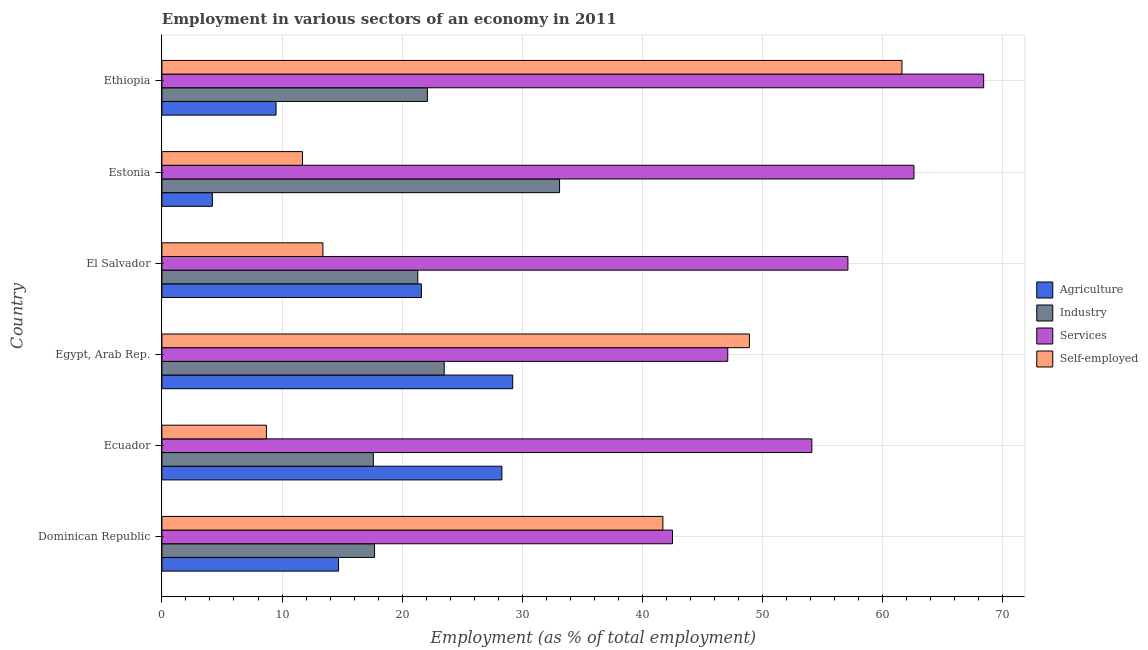How many different coloured bars are there?
Your answer should be very brief. 4. How many groups of bars are there?
Provide a short and direct response. 6. Are the number of bars per tick equal to the number of legend labels?
Give a very brief answer. Yes. Are the number of bars on each tick of the Y-axis equal?
Provide a short and direct response. Yes. How many bars are there on the 4th tick from the top?
Make the answer very short. 4. How many bars are there on the 2nd tick from the bottom?
Make the answer very short. 4. What is the label of the 5th group of bars from the top?
Make the answer very short. Ecuador. In how many cases, is the number of bars for a given country not equal to the number of legend labels?
Provide a succinct answer. 0. What is the percentage of workers in services in Dominican Republic?
Your response must be concise. 42.5. Across all countries, what is the maximum percentage of workers in industry?
Offer a very short reply. 33.1. Across all countries, what is the minimum percentage of workers in agriculture?
Your response must be concise. 4.2. In which country was the percentage of workers in agriculture maximum?
Provide a succinct answer. Egypt, Arab Rep. In which country was the percentage of self employed workers minimum?
Give a very brief answer. Ecuador. What is the total percentage of workers in industry in the graph?
Provide a succinct answer. 135.3. What is the difference between the percentage of workers in services in Dominican Republic and that in Estonia?
Provide a short and direct response. -20.1. What is the difference between the percentage of self employed workers in Ethiopia and the percentage of workers in services in Egypt, Arab Rep.?
Keep it short and to the point. 14.5. What is the average percentage of workers in agriculture per country?
Provide a short and direct response. 17.92. What is the difference between the percentage of workers in agriculture and percentage of workers in industry in Estonia?
Give a very brief answer. -28.9. In how many countries, is the percentage of workers in industry greater than 4 %?
Ensure brevity in your answer.  6. What is the ratio of the percentage of workers in agriculture in Ecuador to that in Ethiopia?
Offer a very short reply. 2.98. Is the percentage of workers in agriculture in Dominican Republic less than that in Ecuador?
Offer a very short reply. Yes. Is the difference between the percentage of workers in services in Estonia and Ethiopia greater than the difference between the percentage of workers in agriculture in Estonia and Ethiopia?
Your answer should be very brief. No. What is the difference between the highest and the lowest percentage of self employed workers?
Offer a terse response. 52.9. In how many countries, is the percentage of workers in industry greater than the average percentage of workers in industry taken over all countries?
Ensure brevity in your answer.  2. Is it the case that in every country, the sum of the percentage of workers in agriculture and percentage of workers in services is greater than the sum of percentage of self employed workers and percentage of workers in industry?
Give a very brief answer. Yes. What does the 3rd bar from the top in Estonia represents?
Keep it short and to the point. Industry. What does the 2nd bar from the bottom in Ecuador represents?
Your answer should be very brief. Industry. Is it the case that in every country, the sum of the percentage of workers in agriculture and percentage of workers in industry is greater than the percentage of workers in services?
Offer a very short reply. No. Are all the bars in the graph horizontal?
Give a very brief answer. Yes. How many countries are there in the graph?
Your answer should be very brief. 6. What is the difference between two consecutive major ticks on the X-axis?
Your response must be concise. 10. Are the values on the major ticks of X-axis written in scientific E-notation?
Provide a short and direct response. No. Does the graph contain any zero values?
Ensure brevity in your answer.  No. Does the graph contain grids?
Your answer should be compact. Yes. Where does the legend appear in the graph?
Provide a short and direct response. Center right. How are the legend labels stacked?
Ensure brevity in your answer.  Vertical. What is the title of the graph?
Offer a terse response. Employment in various sectors of an economy in 2011. Does "Belgium" appear as one of the legend labels in the graph?
Your response must be concise. No. What is the label or title of the X-axis?
Keep it short and to the point. Employment (as % of total employment). What is the Employment (as % of total employment) in Agriculture in Dominican Republic?
Provide a succinct answer. 14.7. What is the Employment (as % of total employment) in Industry in Dominican Republic?
Keep it short and to the point. 17.7. What is the Employment (as % of total employment) in Services in Dominican Republic?
Your answer should be very brief. 42.5. What is the Employment (as % of total employment) of Self-employed in Dominican Republic?
Offer a terse response. 41.7. What is the Employment (as % of total employment) in Agriculture in Ecuador?
Give a very brief answer. 28.3. What is the Employment (as % of total employment) of Industry in Ecuador?
Keep it short and to the point. 17.6. What is the Employment (as % of total employment) in Services in Ecuador?
Your answer should be very brief. 54.1. What is the Employment (as % of total employment) in Self-employed in Ecuador?
Keep it short and to the point. 8.7. What is the Employment (as % of total employment) in Agriculture in Egypt, Arab Rep.?
Your answer should be compact. 29.2. What is the Employment (as % of total employment) of Services in Egypt, Arab Rep.?
Keep it short and to the point. 47.1. What is the Employment (as % of total employment) of Self-employed in Egypt, Arab Rep.?
Make the answer very short. 48.9. What is the Employment (as % of total employment) of Agriculture in El Salvador?
Offer a very short reply. 21.6. What is the Employment (as % of total employment) of Industry in El Salvador?
Make the answer very short. 21.3. What is the Employment (as % of total employment) of Services in El Salvador?
Give a very brief answer. 57.1. What is the Employment (as % of total employment) in Self-employed in El Salvador?
Offer a very short reply. 13.4. What is the Employment (as % of total employment) of Agriculture in Estonia?
Ensure brevity in your answer.  4.2. What is the Employment (as % of total employment) in Industry in Estonia?
Keep it short and to the point. 33.1. What is the Employment (as % of total employment) of Services in Estonia?
Offer a very short reply. 62.6. What is the Employment (as % of total employment) of Self-employed in Estonia?
Provide a succinct answer. 11.7. What is the Employment (as % of total employment) in Agriculture in Ethiopia?
Offer a very short reply. 9.5. What is the Employment (as % of total employment) in Industry in Ethiopia?
Ensure brevity in your answer.  22.1. What is the Employment (as % of total employment) of Services in Ethiopia?
Provide a short and direct response. 68.4. What is the Employment (as % of total employment) of Self-employed in Ethiopia?
Offer a very short reply. 61.6. Across all countries, what is the maximum Employment (as % of total employment) in Agriculture?
Give a very brief answer. 29.2. Across all countries, what is the maximum Employment (as % of total employment) of Industry?
Offer a very short reply. 33.1. Across all countries, what is the maximum Employment (as % of total employment) of Services?
Make the answer very short. 68.4. Across all countries, what is the maximum Employment (as % of total employment) of Self-employed?
Provide a short and direct response. 61.6. Across all countries, what is the minimum Employment (as % of total employment) of Agriculture?
Offer a terse response. 4.2. Across all countries, what is the minimum Employment (as % of total employment) of Industry?
Ensure brevity in your answer.  17.6. Across all countries, what is the minimum Employment (as % of total employment) in Services?
Provide a succinct answer. 42.5. Across all countries, what is the minimum Employment (as % of total employment) of Self-employed?
Your answer should be very brief. 8.7. What is the total Employment (as % of total employment) in Agriculture in the graph?
Provide a succinct answer. 107.5. What is the total Employment (as % of total employment) of Industry in the graph?
Your answer should be compact. 135.3. What is the total Employment (as % of total employment) in Services in the graph?
Give a very brief answer. 331.8. What is the total Employment (as % of total employment) in Self-employed in the graph?
Your answer should be compact. 186. What is the difference between the Employment (as % of total employment) in Services in Dominican Republic and that in Ecuador?
Provide a short and direct response. -11.6. What is the difference between the Employment (as % of total employment) in Self-employed in Dominican Republic and that in Ecuador?
Your response must be concise. 33. What is the difference between the Employment (as % of total employment) of Industry in Dominican Republic and that in Egypt, Arab Rep.?
Provide a short and direct response. -5.8. What is the difference between the Employment (as % of total employment) of Agriculture in Dominican Republic and that in El Salvador?
Make the answer very short. -6.9. What is the difference between the Employment (as % of total employment) in Industry in Dominican Republic and that in El Salvador?
Your answer should be compact. -3.6. What is the difference between the Employment (as % of total employment) in Services in Dominican Republic and that in El Salvador?
Provide a succinct answer. -14.6. What is the difference between the Employment (as % of total employment) of Self-employed in Dominican Republic and that in El Salvador?
Give a very brief answer. 28.3. What is the difference between the Employment (as % of total employment) of Agriculture in Dominican Republic and that in Estonia?
Provide a succinct answer. 10.5. What is the difference between the Employment (as % of total employment) in Industry in Dominican Republic and that in Estonia?
Make the answer very short. -15.4. What is the difference between the Employment (as % of total employment) of Services in Dominican Republic and that in Estonia?
Provide a succinct answer. -20.1. What is the difference between the Employment (as % of total employment) of Agriculture in Dominican Republic and that in Ethiopia?
Keep it short and to the point. 5.2. What is the difference between the Employment (as % of total employment) of Industry in Dominican Republic and that in Ethiopia?
Your answer should be very brief. -4.4. What is the difference between the Employment (as % of total employment) in Services in Dominican Republic and that in Ethiopia?
Your response must be concise. -25.9. What is the difference between the Employment (as % of total employment) in Self-employed in Dominican Republic and that in Ethiopia?
Provide a short and direct response. -19.9. What is the difference between the Employment (as % of total employment) of Agriculture in Ecuador and that in Egypt, Arab Rep.?
Give a very brief answer. -0.9. What is the difference between the Employment (as % of total employment) of Self-employed in Ecuador and that in Egypt, Arab Rep.?
Give a very brief answer. -40.2. What is the difference between the Employment (as % of total employment) of Industry in Ecuador and that in El Salvador?
Offer a very short reply. -3.7. What is the difference between the Employment (as % of total employment) in Services in Ecuador and that in El Salvador?
Provide a short and direct response. -3. What is the difference between the Employment (as % of total employment) in Self-employed in Ecuador and that in El Salvador?
Your response must be concise. -4.7. What is the difference between the Employment (as % of total employment) in Agriculture in Ecuador and that in Estonia?
Make the answer very short. 24.1. What is the difference between the Employment (as % of total employment) of Industry in Ecuador and that in Estonia?
Offer a very short reply. -15.5. What is the difference between the Employment (as % of total employment) of Services in Ecuador and that in Estonia?
Your answer should be compact. -8.5. What is the difference between the Employment (as % of total employment) of Agriculture in Ecuador and that in Ethiopia?
Your answer should be very brief. 18.8. What is the difference between the Employment (as % of total employment) in Services in Ecuador and that in Ethiopia?
Make the answer very short. -14.3. What is the difference between the Employment (as % of total employment) of Self-employed in Ecuador and that in Ethiopia?
Provide a short and direct response. -52.9. What is the difference between the Employment (as % of total employment) of Industry in Egypt, Arab Rep. and that in El Salvador?
Ensure brevity in your answer.  2.2. What is the difference between the Employment (as % of total employment) of Self-employed in Egypt, Arab Rep. and that in El Salvador?
Your answer should be very brief. 35.5. What is the difference between the Employment (as % of total employment) of Services in Egypt, Arab Rep. and that in Estonia?
Provide a short and direct response. -15.5. What is the difference between the Employment (as % of total employment) of Self-employed in Egypt, Arab Rep. and that in Estonia?
Your answer should be very brief. 37.2. What is the difference between the Employment (as % of total employment) in Services in Egypt, Arab Rep. and that in Ethiopia?
Ensure brevity in your answer.  -21.3. What is the difference between the Employment (as % of total employment) of Self-employed in Egypt, Arab Rep. and that in Ethiopia?
Keep it short and to the point. -12.7. What is the difference between the Employment (as % of total employment) in Agriculture in El Salvador and that in Estonia?
Your response must be concise. 17.4. What is the difference between the Employment (as % of total employment) of Industry in El Salvador and that in Estonia?
Your answer should be very brief. -11.8. What is the difference between the Employment (as % of total employment) in Services in El Salvador and that in Estonia?
Your response must be concise. -5.5. What is the difference between the Employment (as % of total employment) in Self-employed in El Salvador and that in Estonia?
Provide a succinct answer. 1.7. What is the difference between the Employment (as % of total employment) in Industry in El Salvador and that in Ethiopia?
Offer a very short reply. -0.8. What is the difference between the Employment (as % of total employment) in Self-employed in El Salvador and that in Ethiopia?
Make the answer very short. -48.2. What is the difference between the Employment (as % of total employment) in Industry in Estonia and that in Ethiopia?
Your answer should be compact. 11. What is the difference between the Employment (as % of total employment) in Services in Estonia and that in Ethiopia?
Your answer should be very brief. -5.8. What is the difference between the Employment (as % of total employment) in Self-employed in Estonia and that in Ethiopia?
Ensure brevity in your answer.  -49.9. What is the difference between the Employment (as % of total employment) of Agriculture in Dominican Republic and the Employment (as % of total employment) of Industry in Ecuador?
Ensure brevity in your answer.  -2.9. What is the difference between the Employment (as % of total employment) of Agriculture in Dominican Republic and the Employment (as % of total employment) of Services in Ecuador?
Your answer should be very brief. -39.4. What is the difference between the Employment (as % of total employment) of Agriculture in Dominican Republic and the Employment (as % of total employment) of Self-employed in Ecuador?
Provide a short and direct response. 6. What is the difference between the Employment (as % of total employment) of Industry in Dominican Republic and the Employment (as % of total employment) of Services in Ecuador?
Keep it short and to the point. -36.4. What is the difference between the Employment (as % of total employment) in Industry in Dominican Republic and the Employment (as % of total employment) in Self-employed in Ecuador?
Offer a very short reply. 9. What is the difference between the Employment (as % of total employment) in Services in Dominican Republic and the Employment (as % of total employment) in Self-employed in Ecuador?
Provide a succinct answer. 33.8. What is the difference between the Employment (as % of total employment) in Agriculture in Dominican Republic and the Employment (as % of total employment) in Industry in Egypt, Arab Rep.?
Offer a very short reply. -8.8. What is the difference between the Employment (as % of total employment) of Agriculture in Dominican Republic and the Employment (as % of total employment) of Services in Egypt, Arab Rep.?
Your response must be concise. -32.4. What is the difference between the Employment (as % of total employment) in Agriculture in Dominican Republic and the Employment (as % of total employment) in Self-employed in Egypt, Arab Rep.?
Keep it short and to the point. -34.2. What is the difference between the Employment (as % of total employment) of Industry in Dominican Republic and the Employment (as % of total employment) of Services in Egypt, Arab Rep.?
Provide a short and direct response. -29.4. What is the difference between the Employment (as % of total employment) in Industry in Dominican Republic and the Employment (as % of total employment) in Self-employed in Egypt, Arab Rep.?
Provide a succinct answer. -31.2. What is the difference between the Employment (as % of total employment) of Agriculture in Dominican Republic and the Employment (as % of total employment) of Services in El Salvador?
Your answer should be compact. -42.4. What is the difference between the Employment (as % of total employment) in Industry in Dominican Republic and the Employment (as % of total employment) in Services in El Salvador?
Provide a succinct answer. -39.4. What is the difference between the Employment (as % of total employment) of Industry in Dominican Republic and the Employment (as % of total employment) of Self-employed in El Salvador?
Provide a short and direct response. 4.3. What is the difference between the Employment (as % of total employment) in Services in Dominican Republic and the Employment (as % of total employment) in Self-employed in El Salvador?
Offer a very short reply. 29.1. What is the difference between the Employment (as % of total employment) in Agriculture in Dominican Republic and the Employment (as % of total employment) in Industry in Estonia?
Your answer should be very brief. -18.4. What is the difference between the Employment (as % of total employment) of Agriculture in Dominican Republic and the Employment (as % of total employment) of Services in Estonia?
Offer a terse response. -47.9. What is the difference between the Employment (as % of total employment) of Industry in Dominican Republic and the Employment (as % of total employment) of Services in Estonia?
Ensure brevity in your answer.  -44.9. What is the difference between the Employment (as % of total employment) in Industry in Dominican Republic and the Employment (as % of total employment) in Self-employed in Estonia?
Offer a terse response. 6. What is the difference between the Employment (as % of total employment) of Services in Dominican Republic and the Employment (as % of total employment) of Self-employed in Estonia?
Make the answer very short. 30.8. What is the difference between the Employment (as % of total employment) of Agriculture in Dominican Republic and the Employment (as % of total employment) of Industry in Ethiopia?
Provide a succinct answer. -7.4. What is the difference between the Employment (as % of total employment) of Agriculture in Dominican Republic and the Employment (as % of total employment) of Services in Ethiopia?
Offer a terse response. -53.7. What is the difference between the Employment (as % of total employment) of Agriculture in Dominican Republic and the Employment (as % of total employment) of Self-employed in Ethiopia?
Your response must be concise. -46.9. What is the difference between the Employment (as % of total employment) of Industry in Dominican Republic and the Employment (as % of total employment) of Services in Ethiopia?
Make the answer very short. -50.7. What is the difference between the Employment (as % of total employment) in Industry in Dominican Republic and the Employment (as % of total employment) in Self-employed in Ethiopia?
Offer a terse response. -43.9. What is the difference between the Employment (as % of total employment) in Services in Dominican Republic and the Employment (as % of total employment) in Self-employed in Ethiopia?
Give a very brief answer. -19.1. What is the difference between the Employment (as % of total employment) of Agriculture in Ecuador and the Employment (as % of total employment) of Services in Egypt, Arab Rep.?
Provide a succinct answer. -18.8. What is the difference between the Employment (as % of total employment) in Agriculture in Ecuador and the Employment (as % of total employment) in Self-employed in Egypt, Arab Rep.?
Provide a succinct answer. -20.6. What is the difference between the Employment (as % of total employment) of Industry in Ecuador and the Employment (as % of total employment) of Services in Egypt, Arab Rep.?
Your response must be concise. -29.5. What is the difference between the Employment (as % of total employment) of Industry in Ecuador and the Employment (as % of total employment) of Self-employed in Egypt, Arab Rep.?
Offer a very short reply. -31.3. What is the difference between the Employment (as % of total employment) of Agriculture in Ecuador and the Employment (as % of total employment) of Services in El Salvador?
Make the answer very short. -28.8. What is the difference between the Employment (as % of total employment) of Agriculture in Ecuador and the Employment (as % of total employment) of Self-employed in El Salvador?
Provide a short and direct response. 14.9. What is the difference between the Employment (as % of total employment) of Industry in Ecuador and the Employment (as % of total employment) of Services in El Salvador?
Make the answer very short. -39.5. What is the difference between the Employment (as % of total employment) in Industry in Ecuador and the Employment (as % of total employment) in Self-employed in El Salvador?
Keep it short and to the point. 4.2. What is the difference between the Employment (as % of total employment) of Services in Ecuador and the Employment (as % of total employment) of Self-employed in El Salvador?
Your response must be concise. 40.7. What is the difference between the Employment (as % of total employment) of Agriculture in Ecuador and the Employment (as % of total employment) of Services in Estonia?
Ensure brevity in your answer.  -34.3. What is the difference between the Employment (as % of total employment) in Agriculture in Ecuador and the Employment (as % of total employment) in Self-employed in Estonia?
Provide a short and direct response. 16.6. What is the difference between the Employment (as % of total employment) of Industry in Ecuador and the Employment (as % of total employment) of Services in Estonia?
Ensure brevity in your answer.  -45. What is the difference between the Employment (as % of total employment) of Industry in Ecuador and the Employment (as % of total employment) of Self-employed in Estonia?
Make the answer very short. 5.9. What is the difference between the Employment (as % of total employment) in Services in Ecuador and the Employment (as % of total employment) in Self-employed in Estonia?
Offer a very short reply. 42.4. What is the difference between the Employment (as % of total employment) in Agriculture in Ecuador and the Employment (as % of total employment) in Services in Ethiopia?
Keep it short and to the point. -40.1. What is the difference between the Employment (as % of total employment) of Agriculture in Ecuador and the Employment (as % of total employment) of Self-employed in Ethiopia?
Your answer should be very brief. -33.3. What is the difference between the Employment (as % of total employment) in Industry in Ecuador and the Employment (as % of total employment) in Services in Ethiopia?
Your answer should be very brief. -50.8. What is the difference between the Employment (as % of total employment) of Industry in Ecuador and the Employment (as % of total employment) of Self-employed in Ethiopia?
Give a very brief answer. -44. What is the difference between the Employment (as % of total employment) in Agriculture in Egypt, Arab Rep. and the Employment (as % of total employment) in Industry in El Salvador?
Offer a terse response. 7.9. What is the difference between the Employment (as % of total employment) of Agriculture in Egypt, Arab Rep. and the Employment (as % of total employment) of Services in El Salvador?
Provide a succinct answer. -27.9. What is the difference between the Employment (as % of total employment) of Agriculture in Egypt, Arab Rep. and the Employment (as % of total employment) of Self-employed in El Salvador?
Offer a terse response. 15.8. What is the difference between the Employment (as % of total employment) in Industry in Egypt, Arab Rep. and the Employment (as % of total employment) in Services in El Salvador?
Give a very brief answer. -33.6. What is the difference between the Employment (as % of total employment) in Industry in Egypt, Arab Rep. and the Employment (as % of total employment) in Self-employed in El Salvador?
Provide a short and direct response. 10.1. What is the difference between the Employment (as % of total employment) of Services in Egypt, Arab Rep. and the Employment (as % of total employment) of Self-employed in El Salvador?
Your response must be concise. 33.7. What is the difference between the Employment (as % of total employment) of Agriculture in Egypt, Arab Rep. and the Employment (as % of total employment) of Industry in Estonia?
Keep it short and to the point. -3.9. What is the difference between the Employment (as % of total employment) of Agriculture in Egypt, Arab Rep. and the Employment (as % of total employment) of Services in Estonia?
Ensure brevity in your answer.  -33.4. What is the difference between the Employment (as % of total employment) in Agriculture in Egypt, Arab Rep. and the Employment (as % of total employment) in Self-employed in Estonia?
Offer a very short reply. 17.5. What is the difference between the Employment (as % of total employment) of Industry in Egypt, Arab Rep. and the Employment (as % of total employment) of Services in Estonia?
Offer a terse response. -39.1. What is the difference between the Employment (as % of total employment) in Services in Egypt, Arab Rep. and the Employment (as % of total employment) in Self-employed in Estonia?
Make the answer very short. 35.4. What is the difference between the Employment (as % of total employment) of Agriculture in Egypt, Arab Rep. and the Employment (as % of total employment) of Services in Ethiopia?
Ensure brevity in your answer.  -39.2. What is the difference between the Employment (as % of total employment) of Agriculture in Egypt, Arab Rep. and the Employment (as % of total employment) of Self-employed in Ethiopia?
Offer a very short reply. -32.4. What is the difference between the Employment (as % of total employment) of Industry in Egypt, Arab Rep. and the Employment (as % of total employment) of Services in Ethiopia?
Offer a very short reply. -44.9. What is the difference between the Employment (as % of total employment) in Industry in Egypt, Arab Rep. and the Employment (as % of total employment) in Self-employed in Ethiopia?
Your response must be concise. -38.1. What is the difference between the Employment (as % of total employment) in Agriculture in El Salvador and the Employment (as % of total employment) in Services in Estonia?
Your answer should be compact. -41. What is the difference between the Employment (as % of total employment) in Agriculture in El Salvador and the Employment (as % of total employment) in Self-employed in Estonia?
Offer a very short reply. 9.9. What is the difference between the Employment (as % of total employment) in Industry in El Salvador and the Employment (as % of total employment) in Services in Estonia?
Offer a very short reply. -41.3. What is the difference between the Employment (as % of total employment) of Services in El Salvador and the Employment (as % of total employment) of Self-employed in Estonia?
Provide a short and direct response. 45.4. What is the difference between the Employment (as % of total employment) in Agriculture in El Salvador and the Employment (as % of total employment) in Services in Ethiopia?
Your answer should be very brief. -46.8. What is the difference between the Employment (as % of total employment) of Agriculture in El Salvador and the Employment (as % of total employment) of Self-employed in Ethiopia?
Your answer should be compact. -40. What is the difference between the Employment (as % of total employment) of Industry in El Salvador and the Employment (as % of total employment) of Services in Ethiopia?
Offer a very short reply. -47.1. What is the difference between the Employment (as % of total employment) in Industry in El Salvador and the Employment (as % of total employment) in Self-employed in Ethiopia?
Provide a short and direct response. -40.3. What is the difference between the Employment (as % of total employment) in Agriculture in Estonia and the Employment (as % of total employment) in Industry in Ethiopia?
Keep it short and to the point. -17.9. What is the difference between the Employment (as % of total employment) in Agriculture in Estonia and the Employment (as % of total employment) in Services in Ethiopia?
Your answer should be compact. -64.2. What is the difference between the Employment (as % of total employment) in Agriculture in Estonia and the Employment (as % of total employment) in Self-employed in Ethiopia?
Your response must be concise. -57.4. What is the difference between the Employment (as % of total employment) of Industry in Estonia and the Employment (as % of total employment) of Services in Ethiopia?
Offer a terse response. -35.3. What is the difference between the Employment (as % of total employment) of Industry in Estonia and the Employment (as % of total employment) of Self-employed in Ethiopia?
Offer a very short reply. -28.5. What is the average Employment (as % of total employment) of Agriculture per country?
Ensure brevity in your answer.  17.92. What is the average Employment (as % of total employment) in Industry per country?
Provide a short and direct response. 22.55. What is the average Employment (as % of total employment) in Services per country?
Ensure brevity in your answer.  55.3. What is the difference between the Employment (as % of total employment) in Agriculture and Employment (as % of total employment) in Industry in Dominican Republic?
Make the answer very short. -3. What is the difference between the Employment (as % of total employment) in Agriculture and Employment (as % of total employment) in Services in Dominican Republic?
Your response must be concise. -27.8. What is the difference between the Employment (as % of total employment) of Agriculture and Employment (as % of total employment) of Self-employed in Dominican Republic?
Provide a short and direct response. -27. What is the difference between the Employment (as % of total employment) in Industry and Employment (as % of total employment) in Services in Dominican Republic?
Keep it short and to the point. -24.8. What is the difference between the Employment (as % of total employment) in Agriculture and Employment (as % of total employment) in Industry in Ecuador?
Your answer should be very brief. 10.7. What is the difference between the Employment (as % of total employment) in Agriculture and Employment (as % of total employment) in Services in Ecuador?
Provide a succinct answer. -25.8. What is the difference between the Employment (as % of total employment) of Agriculture and Employment (as % of total employment) of Self-employed in Ecuador?
Provide a succinct answer. 19.6. What is the difference between the Employment (as % of total employment) of Industry and Employment (as % of total employment) of Services in Ecuador?
Provide a succinct answer. -36.5. What is the difference between the Employment (as % of total employment) of Industry and Employment (as % of total employment) of Self-employed in Ecuador?
Your answer should be very brief. 8.9. What is the difference between the Employment (as % of total employment) of Services and Employment (as % of total employment) of Self-employed in Ecuador?
Your response must be concise. 45.4. What is the difference between the Employment (as % of total employment) in Agriculture and Employment (as % of total employment) in Services in Egypt, Arab Rep.?
Your answer should be very brief. -17.9. What is the difference between the Employment (as % of total employment) in Agriculture and Employment (as % of total employment) in Self-employed in Egypt, Arab Rep.?
Give a very brief answer. -19.7. What is the difference between the Employment (as % of total employment) of Industry and Employment (as % of total employment) of Services in Egypt, Arab Rep.?
Your answer should be compact. -23.6. What is the difference between the Employment (as % of total employment) of Industry and Employment (as % of total employment) of Self-employed in Egypt, Arab Rep.?
Offer a very short reply. -25.4. What is the difference between the Employment (as % of total employment) in Agriculture and Employment (as % of total employment) in Services in El Salvador?
Keep it short and to the point. -35.5. What is the difference between the Employment (as % of total employment) in Industry and Employment (as % of total employment) in Services in El Salvador?
Provide a short and direct response. -35.8. What is the difference between the Employment (as % of total employment) of Services and Employment (as % of total employment) of Self-employed in El Salvador?
Provide a short and direct response. 43.7. What is the difference between the Employment (as % of total employment) in Agriculture and Employment (as % of total employment) in Industry in Estonia?
Provide a succinct answer. -28.9. What is the difference between the Employment (as % of total employment) in Agriculture and Employment (as % of total employment) in Services in Estonia?
Provide a short and direct response. -58.4. What is the difference between the Employment (as % of total employment) in Agriculture and Employment (as % of total employment) in Self-employed in Estonia?
Make the answer very short. -7.5. What is the difference between the Employment (as % of total employment) in Industry and Employment (as % of total employment) in Services in Estonia?
Offer a very short reply. -29.5. What is the difference between the Employment (as % of total employment) of Industry and Employment (as % of total employment) of Self-employed in Estonia?
Your response must be concise. 21.4. What is the difference between the Employment (as % of total employment) in Services and Employment (as % of total employment) in Self-employed in Estonia?
Ensure brevity in your answer.  50.9. What is the difference between the Employment (as % of total employment) in Agriculture and Employment (as % of total employment) in Services in Ethiopia?
Give a very brief answer. -58.9. What is the difference between the Employment (as % of total employment) in Agriculture and Employment (as % of total employment) in Self-employed in Ethiopia?
Offer a very short reply. -52.1. What is the difference between the Employment (as % of total employment) in Industry and Employment (as % of total employment) in Services in Ethiopia?
Offer a terse response. -46.3. What is the difference between the Employment (as % of total employment) of Industry and Employment (as % of total employment) of Self-employed in Ethiopia?
Your answer should be compact. -39.5. What is the difference between the Employment (as % of total employment) in Services and Employment (as % of total employment) in Self-employed in Ethiopia?
Your response must be concise. 6.8. What is the ratio of the Employment (as % of total employment) in Agriculture in Dominican Republic to that in Ecuador?
Provide a succinct answer. 0.52. What is the ratio of the Employment (as % of total employment) in Industry in Dominican Republic to that in Ecuador?
Your answer should be compact. 1.01. What is the ratio of the Employment (as % of total employment) in Services in Dominican Republic to that in Ecuador?
Your answer should be very brief. 0.79. What is the ratio of the Employment (as % of total employment) of Self-employed in Dominican Republic to that in Ecuador?
Give a very brief answer. 4.79. What is the ratio of the Employment (as % of total employment) in Agriculture in Dominican Republic to that in Egypt, Arab Rep.?
Ensure brevity in your answer.  0.5. What is the ratio of the Employment (as % of total employment) of Industry in Dominican Republic to that in Egypt, Arab Rep.?
Provide a succinct answer. 0.75. What is the ratio of the Employment (as % of total employment) of Services in Dominican Republic to that in Egypt, Arab Rep.?
Ensure brevity in your answer.  0.9. What is the ratio of the Employment (as % of total employment) of Self-employed in Dominican Republic to that in Egypt, Arab Rep.?
Make the answer very short. 0.85. What is the ratio of the Employment (as % of total employment) in Agriculture in Dominican Republic to that in El Salvador?
Your answer should be compact. 0.68. What is the ratio of the Employment (as % of total employment) in Industry in Dominican Republic to that in El Salvador?
Make the answer very short. 0.83. What is the ratio of the Employment (as % of total employment) of Services in Dominican Republic to that in El Salvador?
Ensure brevity in your answer.  0.74. What is the ratio of the Employment (as % of total employment) of Self-employed in Dominican Republic to that in El Salvador?
Give a very brief answer. 3.11. What is the ratio of the Employment (as % of total employment) of Industry in Dominican Republic to that in Estonia?
Ensure brevity in your answer.  0.53. What is the ratio of the Employment (as % of total employment) of Services in Dominican Republic to that in Estonia?
Keep it short and to the point. 0.68. What is the ratio of the Employment (as % of total employment) in Self-employed in Dominican Republic to that in Estonia?
Your answer should be very brief. 3.56. What is the ratio of the Employment (as % of total employment) of Agriculture in Dominican Republic to that in Ethiopia?
Give a very brief answer. 1.55. What is the ratio of the Employment (as % of total employment) in Industry in Dominican Republic to that in Ethiopia?
Make the answer very short. 0.8. What is the ratio of the Employment (as % of total employment) in Services in Dominican Republic to that in Ethiopia?
Ensure brevity in your answer.  0.62. What is the ratio of the Employment (as % of total employment) in Self-employed in Dominican Republic to that in Ethiopia?
Offer a terse response. 0.68. What is the ratio of the Employment (as % of total employment) of Agriculture in Ecuador to that in Egypt, Arab Rep.?
Your response must be concise. 0.97. What is the ratio of the Employment (as % of total employment) of Industry in Ecuador to that in Egypt, Arab Rep.?
Make the answer very short. 0.75. What is the ratio of the Employment (as % of total employment) of Services in Ecuador to that in Egypt, Arab Rep.?
Provide a short and direct response. 1.15. What is the ratio of the Employment (as % of total employment) of Self-employed in Ecuador to that in Egypt, Arab Rep.?
Make the answer very short. 0.18. What is the ratio of the Employment (as % of total employment) of Agriculture in Ecuador to that in El Salvador?
Provide a succinct answer. 1.31. What is the ratio of the Employment (as % of total employment) of Industry in Ecuador to that in El Salvador?
Provide a succinct answer. 0.83. What is the ratio of the Employment (as % of total employment) in Services in Ecuador to that in El Salvador?
Ensure brevity in your answer.  0.95. What is the ratio of the Employment (as % of total employment) in Self-employed in Ecuador to that in El Salvador?
Ensure brevity in your answer.  0.65. What is the ratio of the Employment (as % of total employment) of Agriculture in Ecuador to that in Estonia?
Offer a terse response. 6.74. What is the ratio of the Employment (as % of total employment) of Industry in Ecuador to that in Estonia?
Your answer should be very brief. 0.53. What is the ratio of the Employment (as % of total employment) of Services in Ecuador to that in Estonia?
Provide a short and direct response. 0.86. What is the ratio of the Employment (as % of total employment) of Self-employed in Ecuador to that in Estonia?
Give a very brief answer. 0.74. What is the ratio of the Employment (as % of total employment) of Agriculture in Ecuador to that in Ethiopia?
Offer a terse response. 2.98. What is the ratio of the Employment (as % of total employment) in Industry in Ecuador to that in Ethiopia?
Your response must be concise. 0.8. What is the ratio of the Employment (as % of total employment) of Services in Ecuador to that in Ethiopia?
Ensure brevity in your answer.  0.79. What is the ratio of the Employment (as % of total employment) of Self-employed in Ecuador to that in Ethiopia?
Give a very brief answer. 0.14. What is the ratio of the Employment (as % of total employment) in Agriculture in Egypt, Arab Rep. to that in El Salvador?
Keep it short and to the point. 1.35. What is the ratio of the Employment (as % of total employment) of Industry in Egypt, Arab Rep. to that in El Salvador?
Your answer should be compact. 1.1. What is the ratio of the Employment (as % of total employment) of Services in Egypt, Arab Rep. to that in El Salvador?
Offer a very short reply. 0.82. What is the ratio of the Employment (as % of total employment) in Self-employed in Egypt, Arab Rep. to that in El Salvador?
Ensure brevity in your answer.  3.65. What is the ratio of the Employment (as % of total employment) of Agriculture in Egypt, Arab Rep. to that in Estonia?
Offer a terse response. 6.95. What is the ratio of the Employment (as % of total employment) of Industry in Egypt, Arab Rep. to that in Estonia?
Keep it short and to the point. 0.71. What is the ratio of the Employment (as % of total employment) of Services in Egypt, Arab Rep. to that in Estonia?
Provide a succinct answer. 0.75. What is the ratio of the Employment (as % of total employment) of Self-employed in Egypt, Arab Rep. to that in Estonia?
Your answer should be compact. 4.18. What is the ratio of the Employment (as % of total employment) of Agriculture in Egypt, Arab Rep. to that in Ethiopia?
Offer a very short reply. 3.07. What is the ratio of the Employment (as % of total employment) of Industry in Egypt, Arab Rep. to that in Ethiopia?
Make the answer very short. 1.06. What is the ratio of the Employment (as % of total employment) of Services in Egypt, Arab Rep. to that in Ethiopia?
Your answer should be compact. 0.69. What is the ratio of the Employment (as % of total employment) in Self-employed in Egypt, Arab Rep. to that in Ethiopia?
Make the answer very short. 0.79. What is the ratio of the Employment (as % of total employment) in Agriculture in El Salvador to that in Estonia?
Provide a short and direct response. 5.14. What is the ratio of the Employment (as % of total employment) in Industry in El Salvador to that in Estonia?
Provide a short and direct response. 0.64. What is the ratio of the Employment (as % of total employment) in Services in El Salvador to that in Estonia?
Provide a succinct answer. 0.91. What is the ratio of the Employment (as % of total employment) in Self-employed in El Salvador to that in Estonia?
Keep it short and to the point. 1.15. What is the ratio of the Employment (as % of total employment) of Agriculture in El Salvador to that in Ethiopia?
Ensure brevity in your answer.  2.27. What is the ratio of the Employment (as % of total employment) of Industry in El Salvador to that in Ethiopia?
Offer a very short reply. 0.96. What is the ratio of the Employment (as % of total employment) of Services in El Salvador to that in Ethiopia?
Your response must be concise. 0.83. What is the ratio of the Employment (as % of total employment) in Self-employed in El Salvador to that in Ethiopia?
Your answer should be compact. 0.22. What is the ratio of the Employment (as % of total employment) of Agriculture in Estonia to that in Ethiopia?
Make the answer very short. 0.44. What is the ratio of the Employment (as % of total employment) of Industry in Estonia to that in Ethiopia?
Your response must be concise. 1.5. What is the ratio of the Employment (as % of total employment) of Services in Estonia to that in Ethiopia?
Ensure brevity in your answer.  0.92. What is the ratio of the Employment (as % of total employment) of Self-employed in Estonia to that in Ethiopia?
Keep it short and to the point. 0.19. What is the difference between the highest and the second highest Employment (as % of total employment) in Agriculture?
Offer a very short reply. 0.9. What is the difference between the highest and the second highest Employment (as % of total employment) in Services?
Provide a succinct answer. 5.8. What is the difference between the highest and the second highest Employment (as % of total employment) of Self-employed?
Offer a terse response. 12.7. What is the difference between the highest and the lowest Employment (as % of total employment) of Services?
Keep it short and to the point. 25.9. What is the difference between the highest and the lowest Employment (as % of total employment) in Self-employed?
Give a very brief answer. 52.9. 